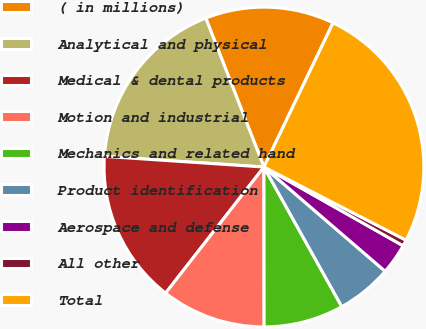<chart> <loc_0><loc_0><loc_500><loc_500><pie_chart><fcel>( in millions)<fcel>Analytical and physical<fcel>Medical & dental products<fcel>Motion and industrial<fcel>Mechanics and related hand<fcel>Product identification<fcel>Aerospace and defense<fcel>All other<fcel>Total<nl><fcel>13.04%<fcel>18.01%<fcel>15.52%<fcel>10.56%<fcel>8.08%<fcel>5.6%<fcel>3.11%<fcel>0.63%<fcel>25.45%<nl></chart> 